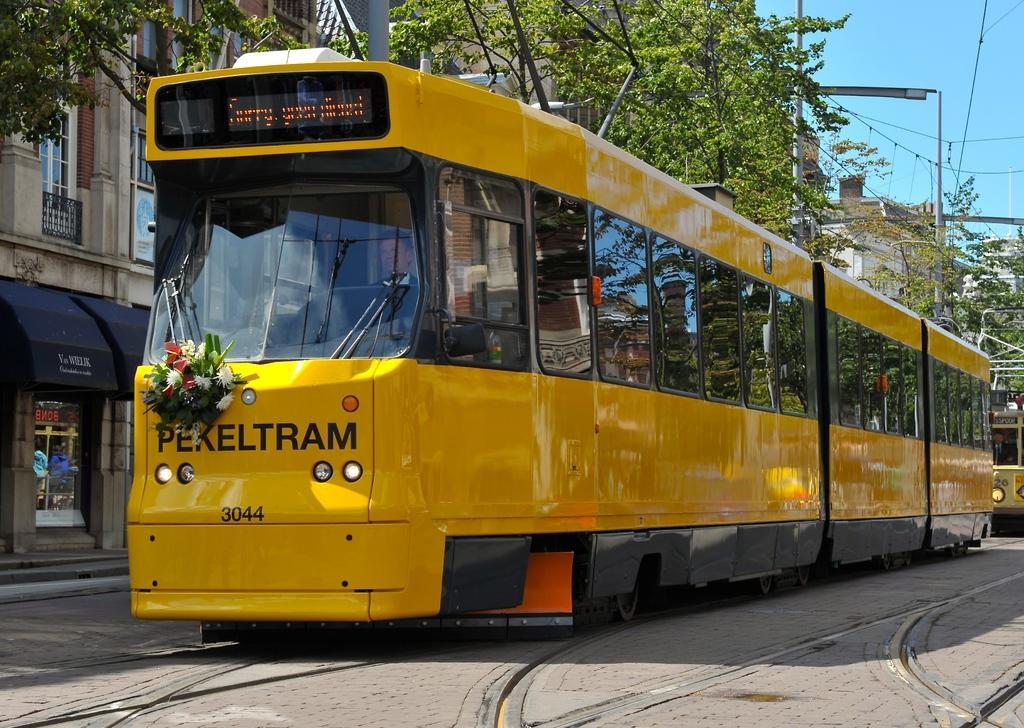Can you describe this image briefly? In this image I can see few buildings, trees, windows, vehicles, stores, poles and wires. The sky is in blue color. 